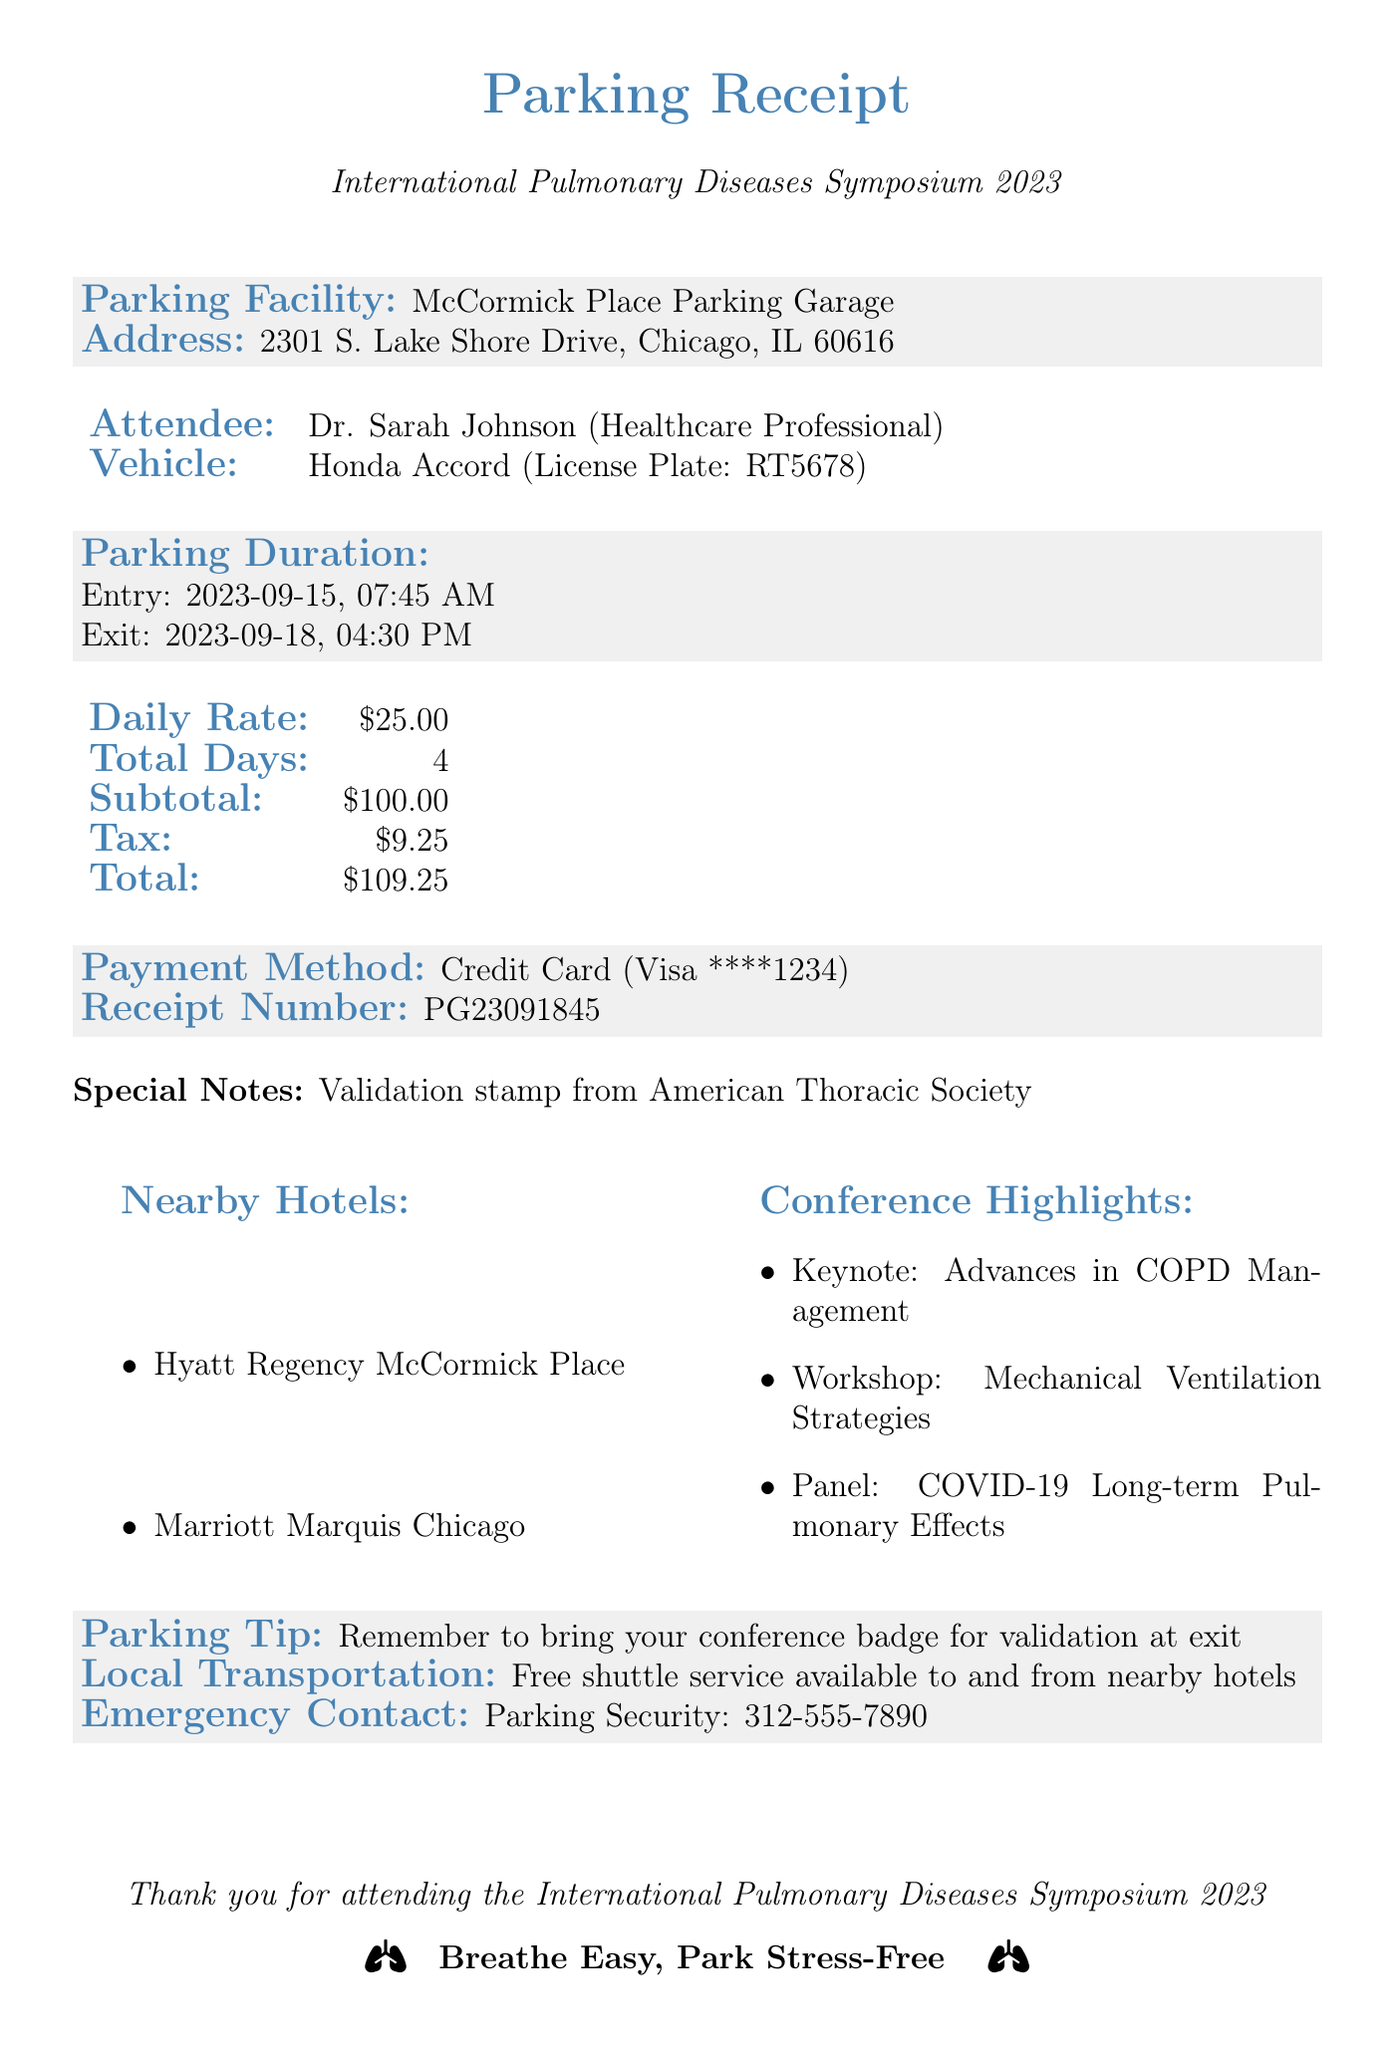What is the conference name? The conference name is referenced at the top of the receipt, indicating the event for which the parking is associated.
Answer: International Pulmonary Diseases Symposium 2023 What is the address of the parking facility? The address is provided specifically for the parking facility mentioned in the receipt.
Answer: 2301 S. Lake Shore Drive, Chicago, IL 60616 What is the daily rate for parking? The daily parking rate is stated in the fees section of the document.
Answer: $25.00 How many total days did the vehicle park? The number of parking days is calculated from the entry and exit dates shared in the document.
Answer: 4 What type of vehicle is listed on the receipt? The document specifies the make and model of the vehicle associated with the parking.
Answer: Honda Accord What was the total parking fee including tax? The total fee combining both the subtotal and tax for parking is presented on the receipt.
Answer: $109.25 Who is the attendee mentioned in the receipt? The attendee's name is presented in the overview section of the document as the individual utilizing the parking services.
Answer: Dr. Sarah Johnson What payment method was used for the parking? The payment method is specified clearly in the document under the payment details.
Answer: Credit Card What special note is included on the receipt? The special note provides additional information about validation related to the parking service.
Answer: Validation stamp from American Thoracic Society 